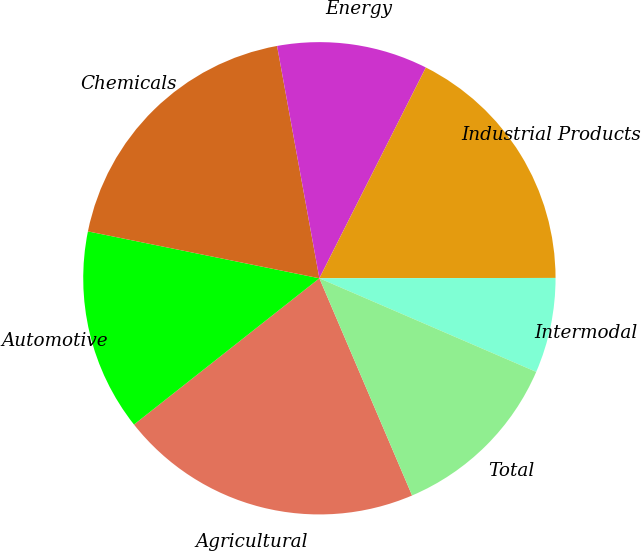<chart> <loc_0><loc_0><loc_500><loc_500><pie_chart><fcel>Agricultural<fcel>Automotive<fcel>Chemicals<fcel>Energy<fcel>Industrial Products<fcel>Intermodal<fcel>Total<nl><fcel>20.79%<fcel>13.81%<fcel>18.95%<fcel>10.31%<fcel>17.53%<fcel>6.51%<fcel>12.09%<nl></chart> 